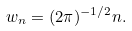<formula> <loc_0><loc_0><loc_500><loc_500>w _ { n } = ( 2 \pi ) ^ { - 1 / 2 } n .</formula> 